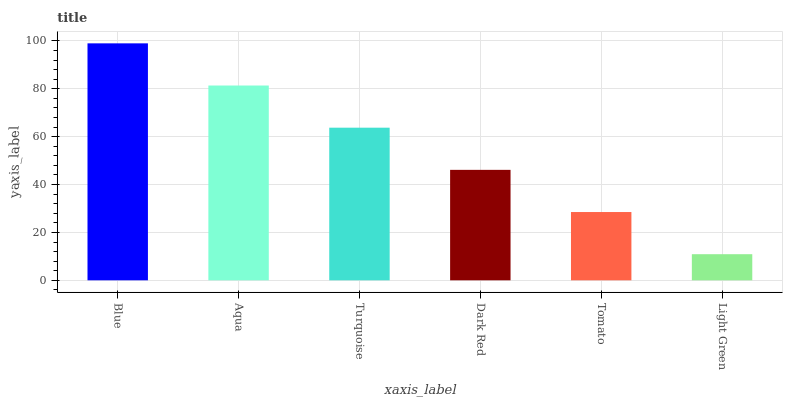Is Aqua the minimum?
Answer yes or no. No. Is Aqua the maximum?
Answer yes or no. No. Is Blue greater than Aqua?
Answer yes or no. Yes. Is Aqua less than Blue?
Answer yes or no. Yes. Is Aqua greater than Blue?
Answer yes or no. No. Is Blue less than Aqua?
Answer yes or no. No. Is Turquoise the high median?
Answer yes or no. Yes. Is Dark Red the low median?
Answer yes or no. Yes. Is Tomato the high median?
Answer yes or no. No. Is Turquoise the low median?
Answer yes or no. No. 